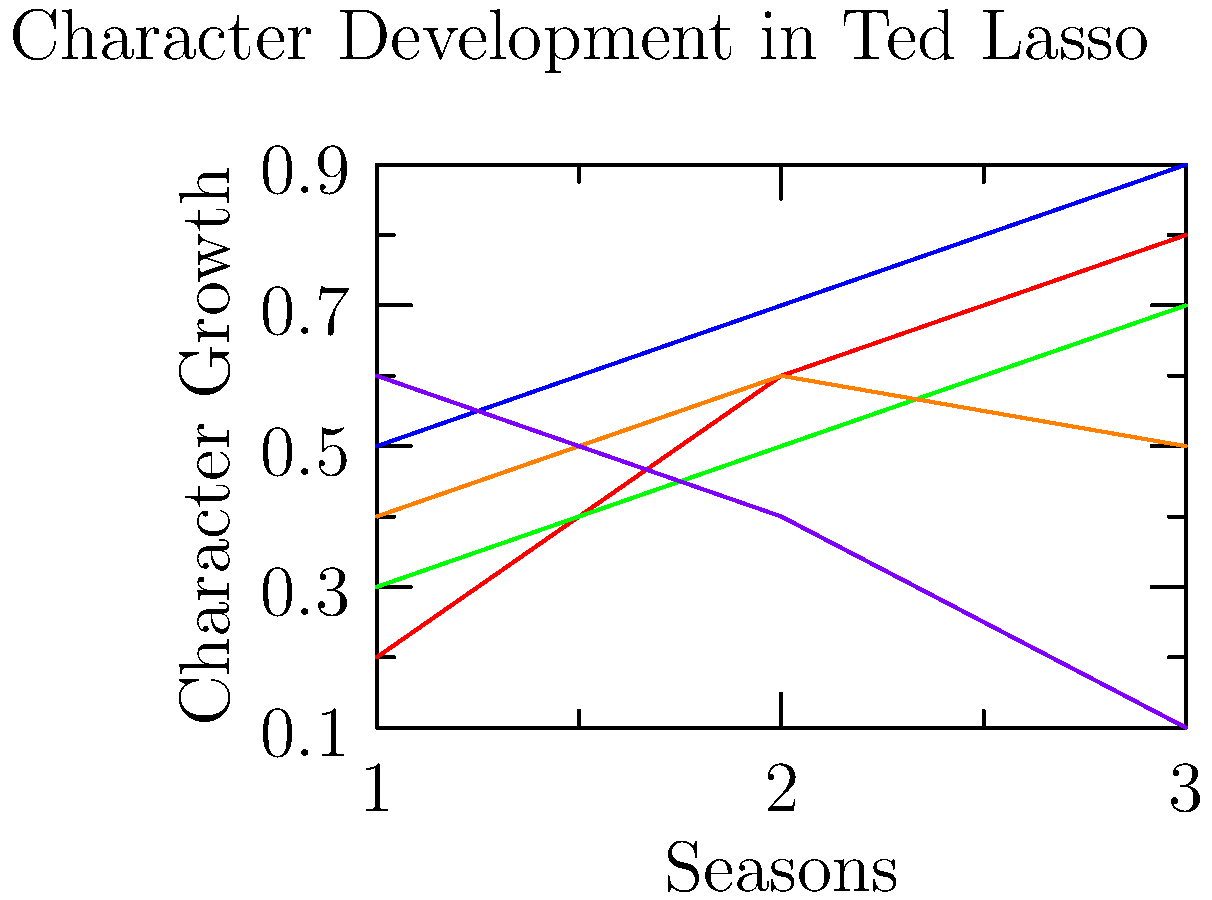Based on the character development arcs shown in the line graph, which character experiences the most dramatic shift from positive to negative growth over the three seasons of Ted Lasso? To answer this question, we need to analyze the trajectories of each character's development arc:

1. Ted (blue line): Shows consistent positive growth from season 1 to 3.
2. Rebecca (red line): Demonstrates steady positive growth throughout all seasons.
3. Roy (green line): Exhibits gradual positive growth across the seasons.
4. Keeley (orange line): Shows initial growth from season 1 to 2, then a slight decline in season 3.
5. Nate (purple line): Begins with positive growth in season 1, then shows a sharp decline in seasons 2 and 3.

Among all characters, Nate's arc stands out as the only one that shifts dramatically from positive to negative growth. His line starts high in season 1, indicating initial positive development, but then drops significantly in seasons 2 and 3, suggesting a negative character arc.

This arc aligns with Nate's storyline in the show, where he starts as an underdog who gains confidence but eventually becomes antagonistic towards Ted and the team.
Answer: Nate 